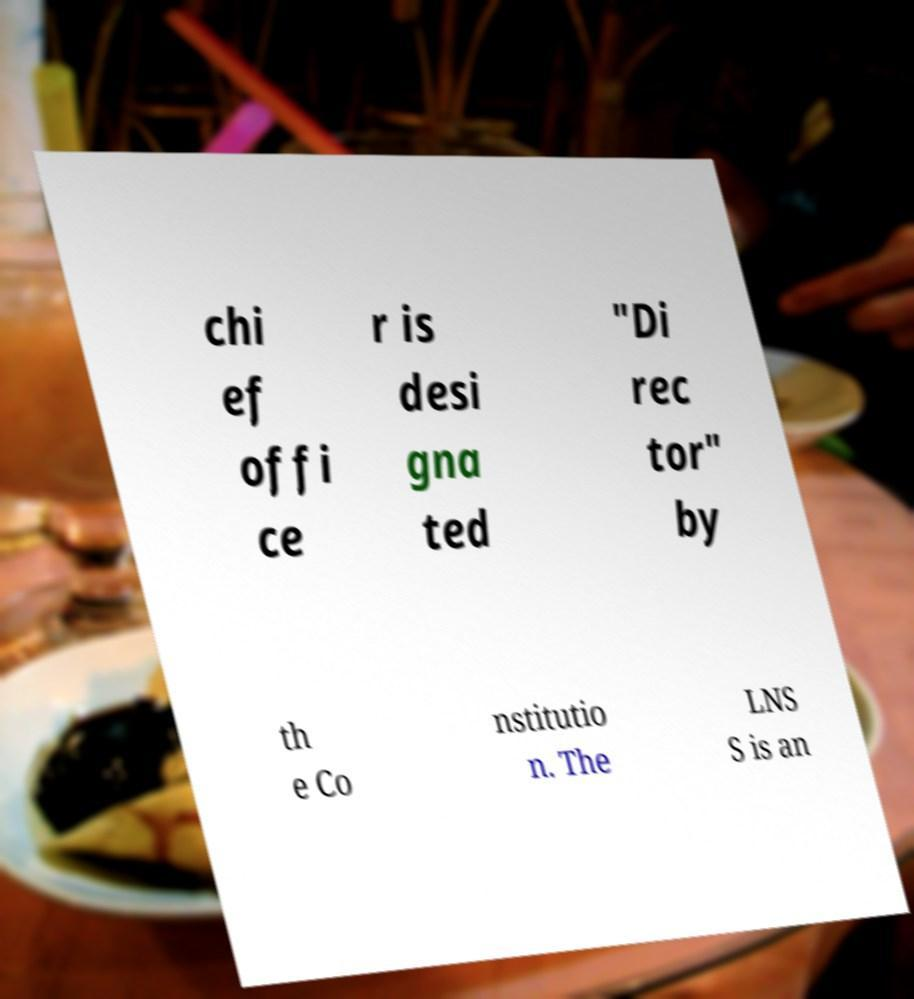Please read and relay the text visible in this image. What does it say? chi ef offi ce r is desi gna ted "Di rec tor" by th e Co nstitutio n. The LNS S is an 